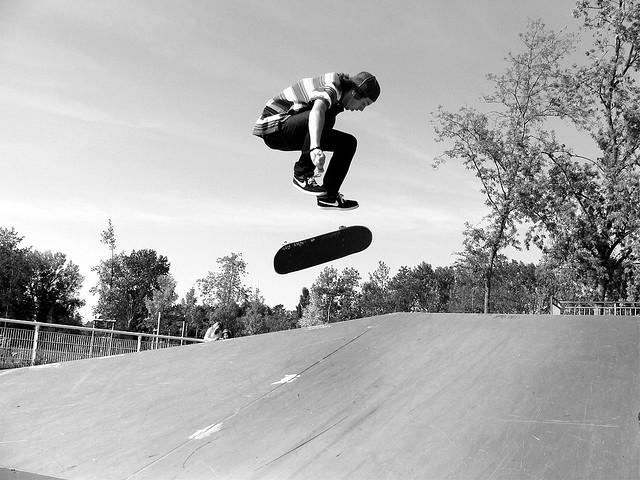What kind of shoes is the skater wearing? Please explain your reasoning. nike. There is a elongated check mark on the side of the shoe. 